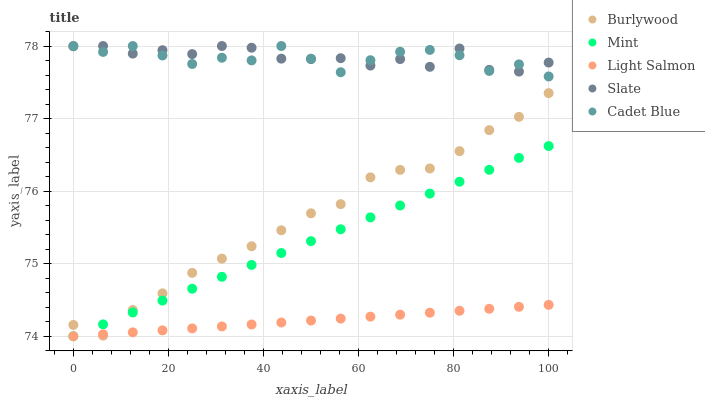Does Light Salmon have the minimum area under the curve?
Answer yes or no. Yes. Does Slate have the maximum area under the curve?
Answer yes or no. Yes. Does Cadet Blue have the minimum area under the curve?
Answer yes or no. No. Does Cadet Blue have the maximum area under the curve?
Answer yes or no. No. Is Mint the smoothest?
Answer yes or no. Yes. Is Slate the roughest?
Answer yes or no. Yes. Is Light Salmon the smoothest?
Answer yes or no. No. Is Light Salmon the roughest?
Answer yes or no. No. Does Light Salmon have the lowest value?
Answer yes or no. Yes. Does Cadet Blue have the lowest value?
Answer yes or no. No. Does Slate have the highest value?
Answer yes or no. Yes. Does Light Salmon have the highest value?
Answer yes or no. No. Is Light Salmon less than Cadet Blue?
Answer yes or no. Yes. Is Cadet Blue greater than Burlywood?
Answer yes or no. Yes. Does Burlywood intersect Mint?
Answer yes or no. Yes. Is Burlywood less than Mint?
Answer yes or no. No. Is Burlywood greater than Mint?
Answer yes or no. No. Does Light Salmon intersect Cadet Blue?
Answer yes or no. No. 